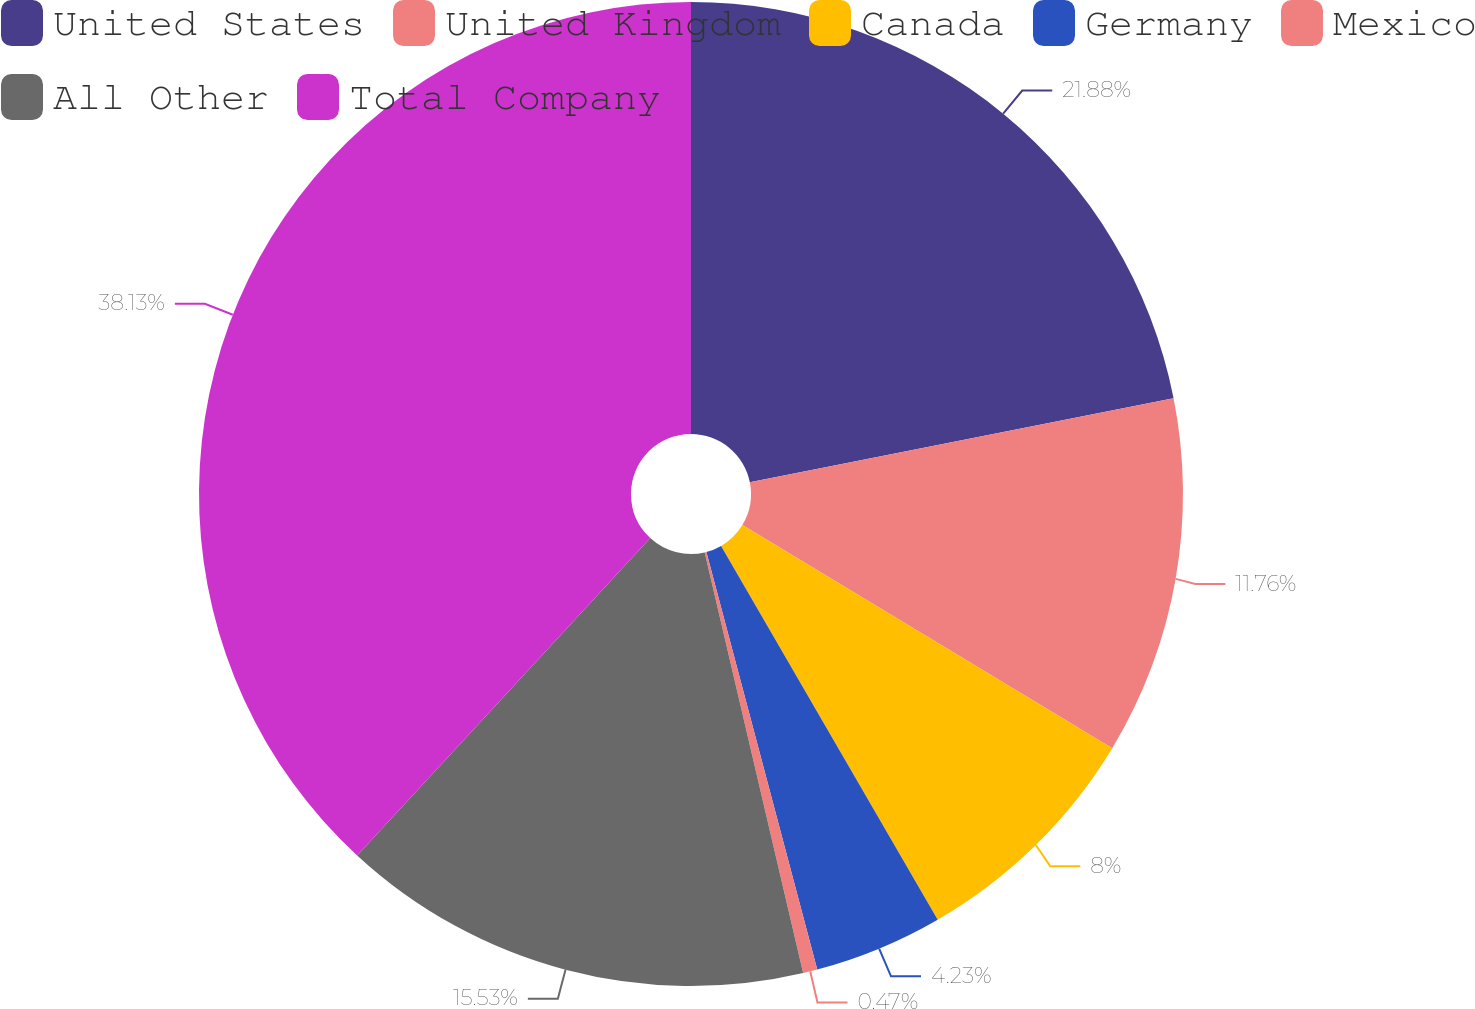Convert chart to OTSL. <chart><loc_0><loc_0><loc_500><loc_500><pie_chart><fcel>United States<fcel>United Kingdom<fcel>Canada<fcel>Germany<fcel>Mexico<fcel>All Other<fcel>Total Company<nl><fcel>21.88%<fcel>11.76%<fcel>8.0%<fcel>4.23%<fcel>0.47%<fcel>15.53%<fcel>38.13%<nl></chart> 